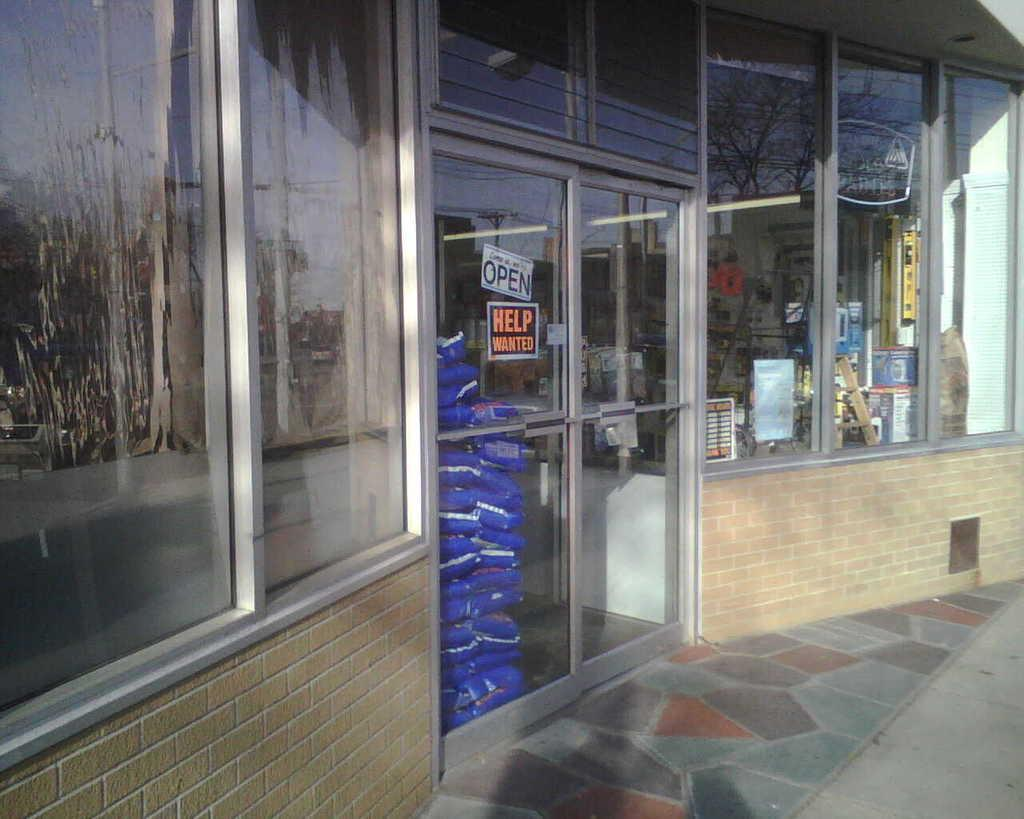<image>
Provide a brief description of the given image. A help wanted sign is posted on the front door, 